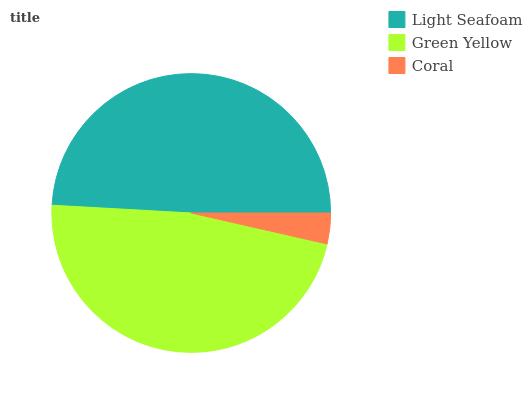Is Coral the minimum?
Answer yes or no. Yes. Is Light Seafoam the maximum?
Answer yes or no. Yes. Is Green Yellow the minimum?
Answer yes or no. No. Is Green Yellow the maximum?
Answer yes or no. No. Is Light Seafoam greater than Green Yellow?
Answer yes or no. Yes. Is Green Yellow less than Light Seafoam?
Answer yes or no. Yes. Is Green Yellow greater than Light Seafoam?
Answer yes or no. No. Is Light Seafoam less than Green Yellow?
Answer yes or no. No. Is Green Yellow the high median?
Answer yes or no. Yes. Is Green Yellow the low median?
Answer yes or no. Yes. Is Coral the high median?
Answer yes or no. No. Is Light Seafoam the low median?
Answer yes or no. No. 